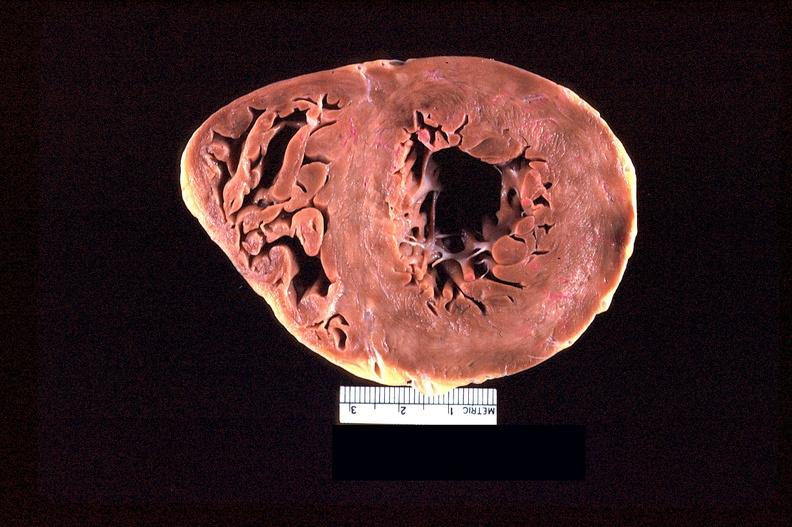does muscle atrophy show heart slice, acute posterior myocardial infarction in patient with hypertension?
Answer the question using a single word or phrase. No 